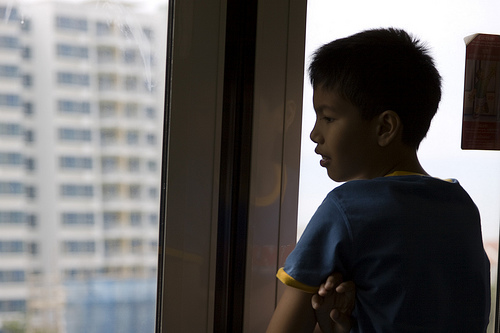<image>
Is there a boy behind the window? Yes. From this viewpoint, the boy is positioned behind the window, with the window partially or fully occluding the boy. 